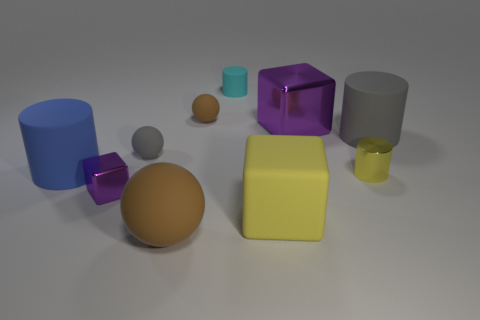How many things are tiny brown metallic cubes or tiny cyan cylinders? In the image, one could observe several geometric shapes of varied colors and sizes. Among them, there appears to be only one tiny cyan cylinder and no tiny brown metallic cubes, making the total count one. However, please note that material properties such as 'metallic' cannot be conclusively determined from a static image without additional context or information. 